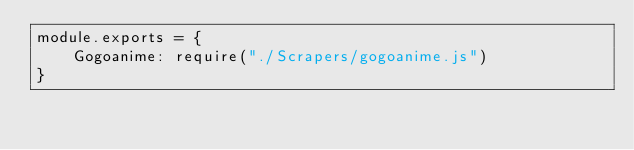<code> <loc_0><loc_0><loc_500><loc_500><_JavaScript_>module.exports = {
	Gogoanime: require("./Scrapers/gogoanime.js")
}


</code> 